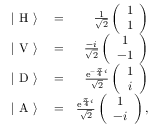<formula> <loc_0><loc_0><loc_500><loc_500>\begin{array} { r l r } { | \ H \ \rangle } & = } & { \frac { 1 } { \sqrt { 2 } } \left ( \begin{array} { c } { 1 } \\ { 1 } \end{array} \right ) } \\ { | \ V \ \rangle } & = } & { \frac { - i } { \sqrt { 2 } } \left ( \begin{array} { c } { 1 } \\ { - 1 } \end{array} \right ) } \\ { | \ D \ \rangle } & = } & { \frac { e ^ { - \frac { \pi } { 4 } i } } { \sqrt { 2 } } \left ( \begin{array} { c } { 1 } \\ { i } \end{array} \right ) } \\ { | \ A \ \rangle } & = } & { \frac { e ^ { \frac { \pi } { 4 } i } } { \sqrt { 2 } } \left ( \begin{array} { c } { 1 } \\ { - i } \end{array} \right ) , } \end{array}</formula> 